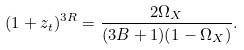Convert formula to latex. <formula><loc_0><loc_0><loc_500><loc_500>( 1 + z _ { t } ) ^ { 3 R } = \frac { 2 \Omega _ { X } } { ( 3 B + 1 ) ( 1 - \Omega _ { X } ) } .</formula> 